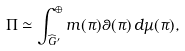Convert formula to latex. <formula><loc_0><loc_0><loc_500><loc_500>\Pi \simeq \int _ { \widehat { G } ^ { \prime } } ^ { \oplus } m ( \pi ) \theta ( \pi ) \, d \mu ( \pi ) ,</formula> 